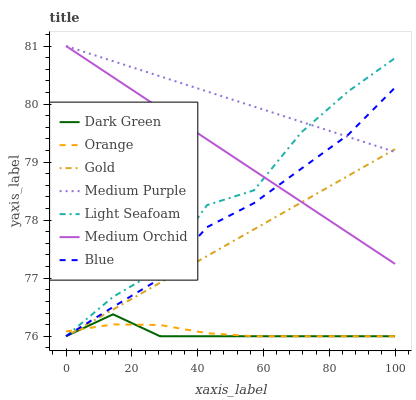Does Dark Green have the minimum area under the curve?
Answer yes or no. Yes. Does Medium Purple have the maximum area under the curve?
Answer yes or no. Yes. Does Gold have the minimum area under the curve?
Answer yes or no. No. Does Gold have the maximum area under the curve?
Answer yes or no. No. Is Medium Orchid the smoothest?
Answer yes or no. Yes. Is Light Seafoam the roughest?
Answer yes or no. Yes. Is Gold the smoothest?
Answer yes or no. No. Is Gold the roughest?
Answer yes or no. No. Does Blue have the lowest value?
Answer yes or no. Yes. Does Medium Orchid have the lowest value?
Answer yes or no. No. Does Medium Purple have the highest value?
Answer yes or no. Yes. Does Gold have the highest value?
Answer yes or no. No. Is Orange less than Medium Purple?
Answer yes or no. Yes. Is Medium Purple greater than Dark Green?
Answer yes or no. Yes. Does Light Seafoam intersect Medium Purple?
Answer yes or no. Yes. Is Light Seafoam less than Medium Purple?
Answer yes or no. No. Is Light Seafoam greater than Medium Purple?
Answer yes or no. No. Does Orange intersect Medium Purple?
Answer yes or no. No. 